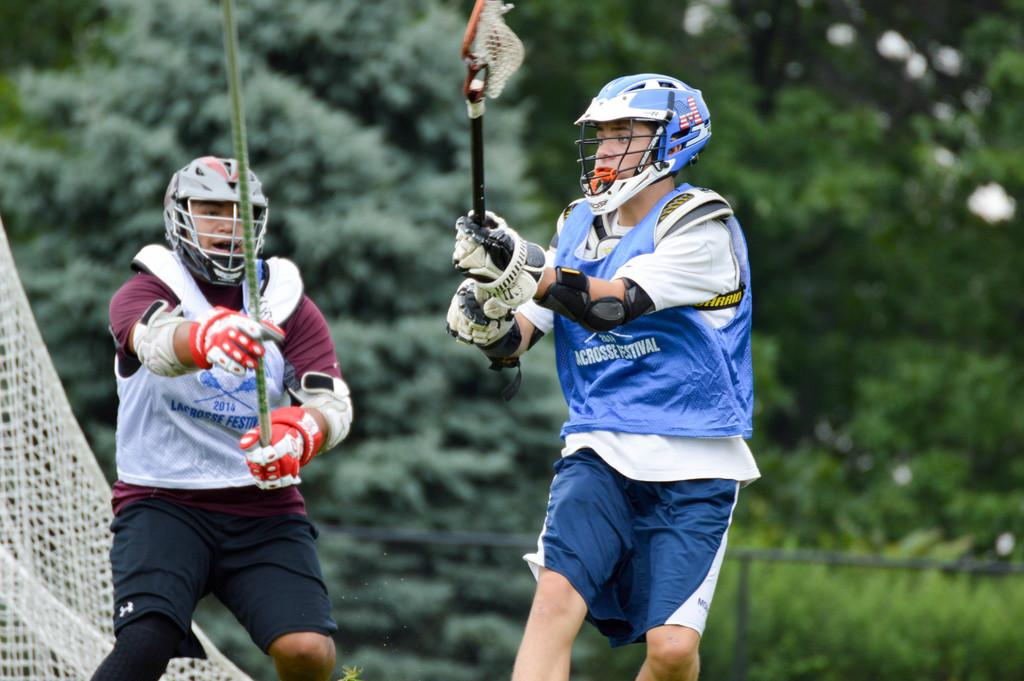How many players are involved in the game shown in the image? There are two players in the image. What sport are the players engaged in? The players are playing a lacrosse game. What can be seen in the background of the image? There are trees in the background of the image. What equipment are the players using to play the game? Both players are holding lacrosse sticks. Can you see any fear in the players' faces as they play the game? The image does not show the players' faces, so it is not possible to determine if they are experiencing fear. 